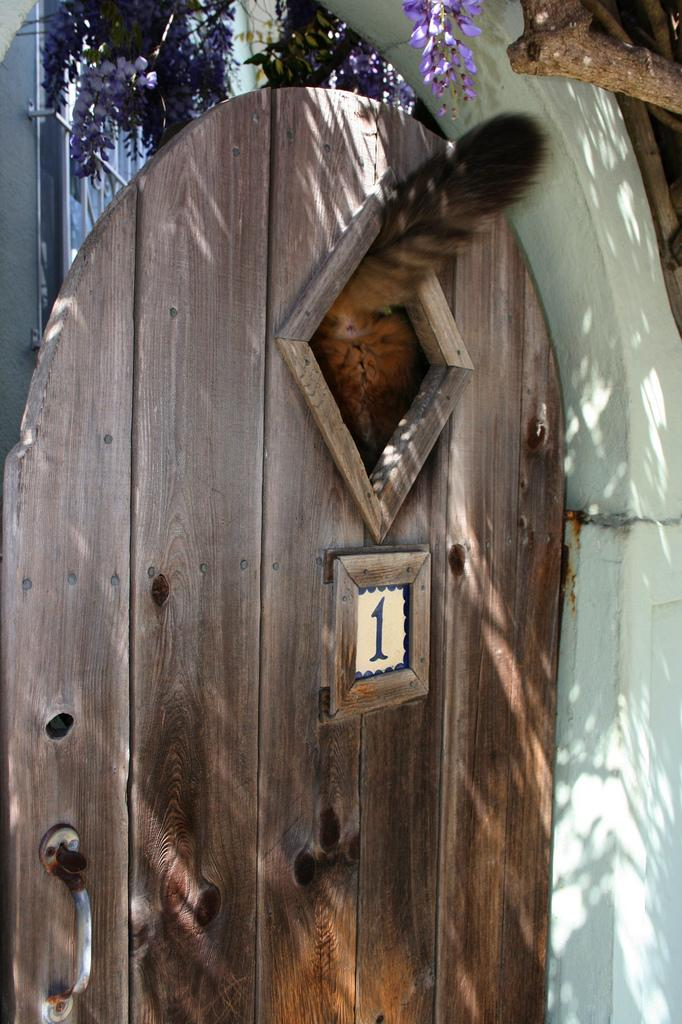What type of animal can be seen in the image? There is an animal in the image, but its specific type cannot be determined from the provided facts. Where is the animal located in the image? The animal is in a den in the image. What can be seen in the background of the image? There is a tree and a building in the background of the image. Who is the creator of the den in the image? The provided facts do not mention a creator for the den, so it cannot be determined from the image. How many crows are visible in the image? There are no crows present in the image. 